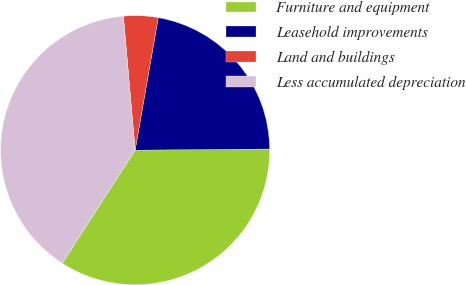Convert chart to OTSL. <chart><loc_0><loc_0><loc_500><loc_500><pie_chart><fcel>Furniture and equipment<fcel>Leasehold improvements<fcel>Land and buildings<fcel>Less accumulated depreciation<nl><fcel>34.26%<fcel>22.11%<fcel>4.14%<fcel>39.5%<nl></chart> 